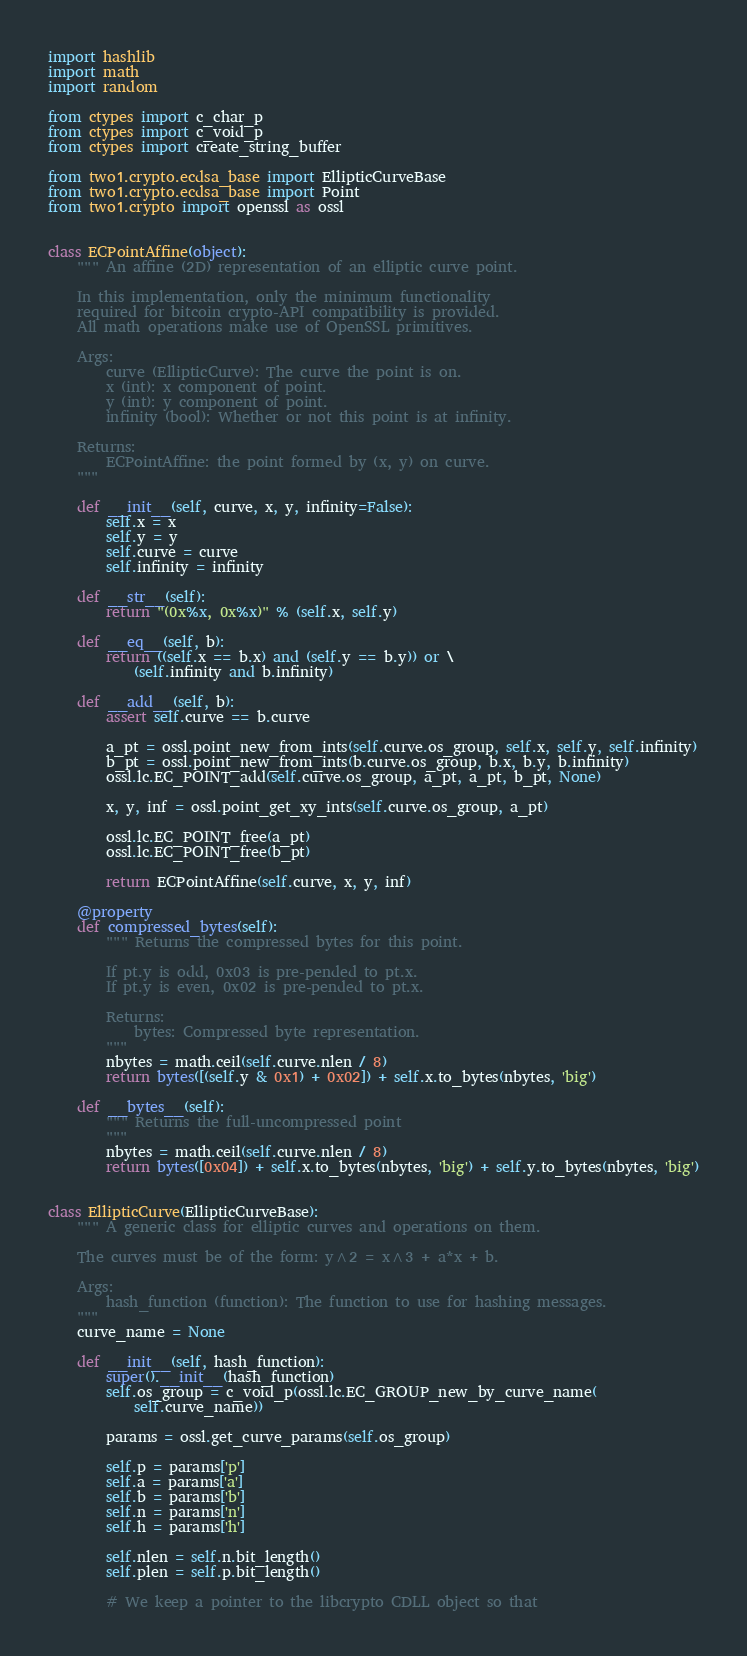Convert code to text. <code><loc_0><loc_0><loc_500><loc_500><_Python_>import hashlib
import math
import random

from ctypes import c_char_p
from ctypes import c_void_p
from ctypes import create_string_buffer

from two1.crypto.ecdsa_base import EllipticCurveBase
from two1.crypto.ecdsa_base import Point
from two1.crypto import openssl as ossl


class ECPointAffine(object):
    """ An affine (2D) representation of an elliptic curve point.

    In this implementation, only the minimum functionality
    required for bitcoin crypto-API compatibility is provided.
    All math operations make use of OpenSSL primitives.

    Args:
        curve (EllipticCurve): The curve the point is on.
        x (int): x component of point.
        y (int): y component of point.
        infinity (bool): Whether or not this point is at infinity.

    Returns:
        ECPointAffine: the point formed by (x, y) on curve.
    """

    def __init__(self, curve, x, y, infinity=False):
        self.x = x
        self.y = y
        self.curve = curve
        self.infinity = infinity

    def __str__(self):
        return "(0x%x, 0x%x)" % (self.x, self.y)

    def __eq__(self, b):
        return ((self.x == b.x) and (self.y == b.y)) or \
            (self.infinity and b.infinity)

    def __add__(self, b):
        assert self.curve == b.curve

        a_pt = ossl.point_new_from_ints(self.curve.os_group, self.x, self.y, self.infinity)
        b_pt = ossl.point_new_from_ints(b.curve.os_group, b.x, b.y, b.infinity)
        ossl.lc.EC_POINT_add(self.curve.os_group, a_pt, a_pt, b_pt, None)

        x, y, inf = ossl.point_get_xy_ints(self.curve.os_group, a_pt)

        ossl.lc.EC_POINT_free(a_pt)
        ossl.lc.EC_POINT_free(b_pt)

        return ECPointAffine(self.curve, x, y, inf)

    @property
    def compressed_bytes(self):
        """ Returns the compressed bytes for this point.

        If pt.y is odd, 0x03 is pre-pended to pt.x.
        If pt.y is even, 0x02 is pre-pended to pt.x.

        Returns:
            bytes: Compressed byte representation.
        """
        nbytes = math.ceil(self.curve.nlen / 8)
        return bytes([(self.y & 0x1) + 0x02]) + self.x.to_bytes(nbytes, 'big')

    def __bytes__(self):
        """ Returns the full-uncompressed point
        """
        nbytes = math.ceil(self.curve.nlen / 8)
        return bytes([0x04]) + self.x.to_bytes(nbytes, 'big') + self.y.to_bytes(nbytes, 'big')


class EllipticCurve(EllipticCurveBase):
    """ A generic class for elliptic curves and operations on them.

    The curves must be of the form: y^2 = x^3 + a*x + b.

    Args:
        hash_function (function): The function to use for hashing messages.
    """
    curve_name = None

    def __init__(self, hash_function):
        super().__init__(hash_function)
        self.os_group = c_void_p(ossl.lc.EC_GROUP_new_by_curve_name(
            self.curve_name))

        params = ossl.get_curve_params(self.os_group)

        self.p = params['p']
        self.a = params['a']
        self.b = params['b']
        self.n = params['n']
        self.h = params['h']

        self.nlen = self.n.bit_length()
        self.plen = self.p.bit_length()

        # We keep a pointer to the libcrypto CDLL object so that</code> 